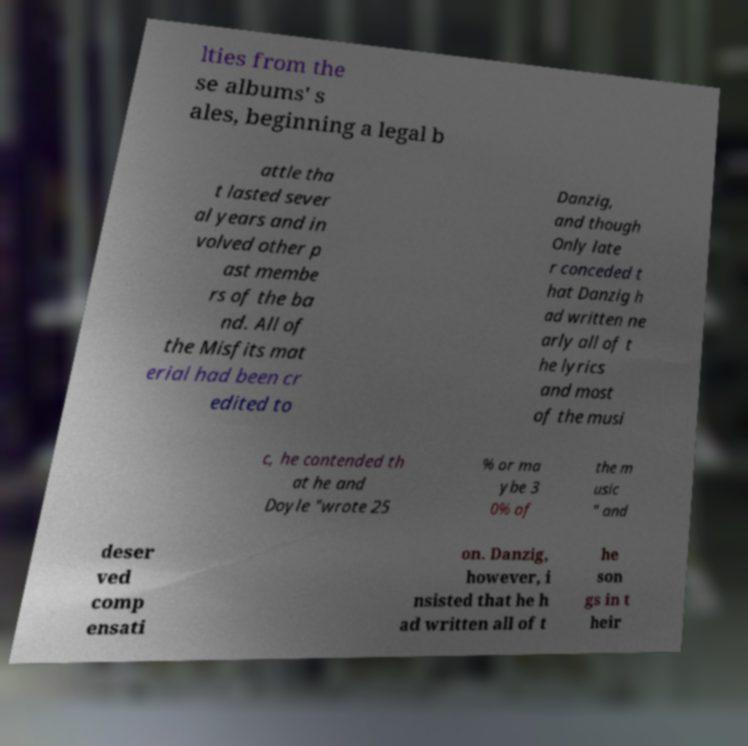Could you assist in decoding the text presented in this image and type it out clearly? lties from the se albums' s ales, beginning a legal b attle tha t lasted sever al years and in volved other p ast membe rs of the ba nd. All of the Misfits mat erial had been cr edited to Danzig, and though Only late r conceded t hat Danzig h ad written ne arly all of t he lyrics and most of the musi c, he contended th at he and Doyle "wrote 25 % or ma ybe 3 0% of the m usic " and deser ved comp ensati on. Danzig, however, i nsisted that he h ad written all of t he son gs in t heir 